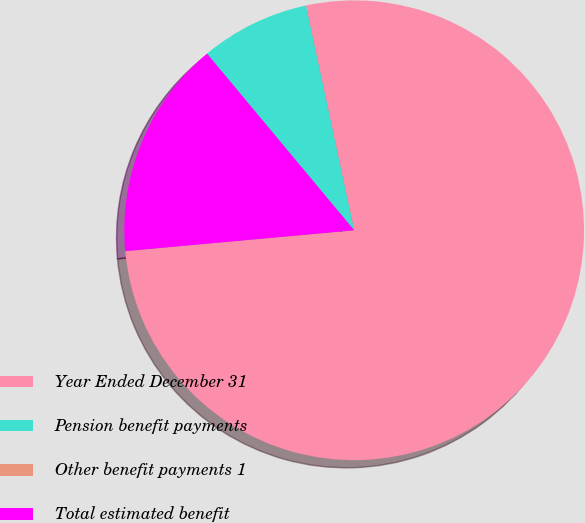<chart> <loc_0><loc_0><loc_500><loc_500><pie_chart><fcel>Year Ended December 31<fcel>Pension benefit payments<fcel>Other benefit payments 1<fcel>Total estimated benefit<nl><fcel>76.92%<fcel>7.69%<fcel>0.0%<fcel>15.39%<nl></chart> 